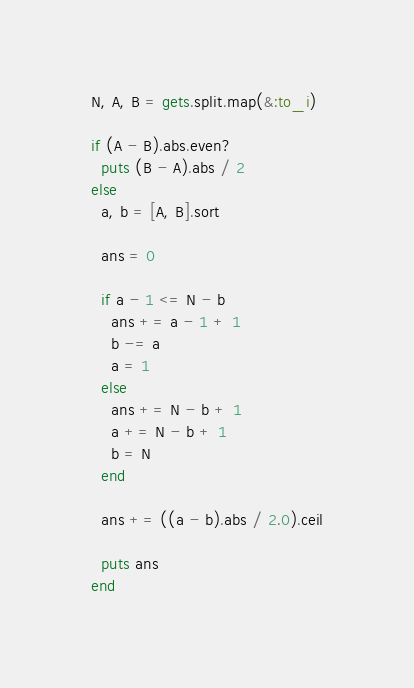Convert code to text. <code><loc_0><loc_0><loc_500><loc_500><_Ruby_>N, A, B = gets.split.map(&:to_i)

if (A - B).abs.even?
  puts (B - A).abs / 2
else
  a, b = [A, B].sort

  ans = 0

  if a - 1 <= N - b
    ans += a - 1 + 1
    b -= a
    a = 1
  else
    ans += N - b + 1
    a += N - b + 1
    b = N
  end

  ans += ((a - b).abs / 2.0).ceil

  puts ans
end
</code> 